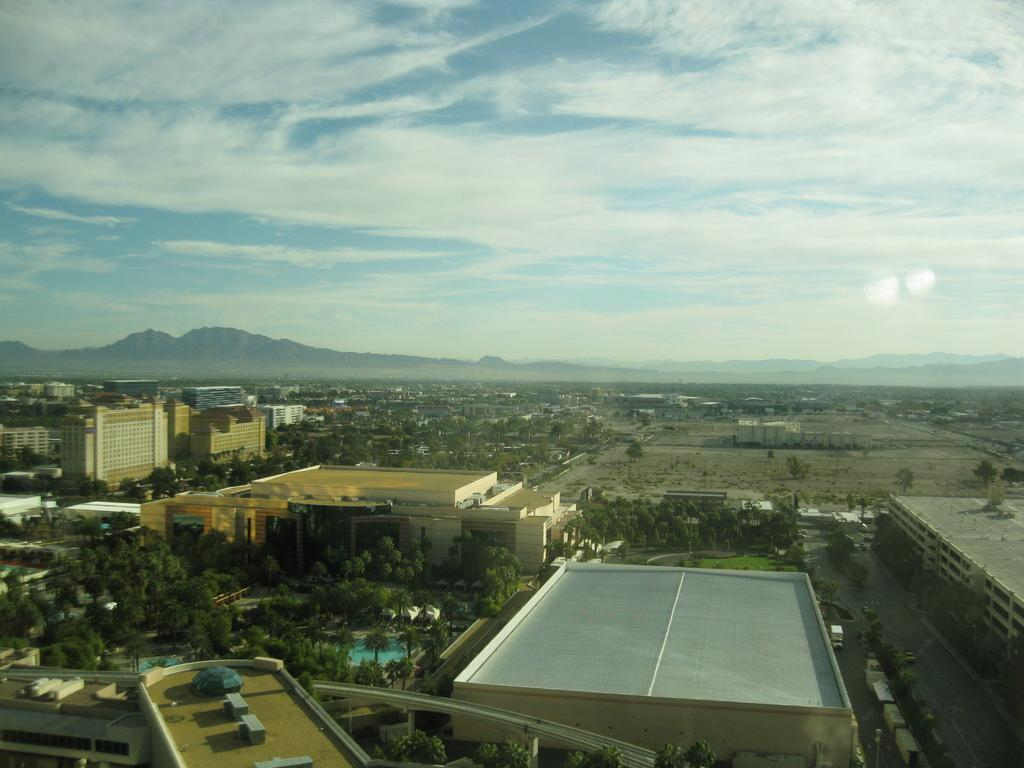What type of structures can be seen in the image? There are buildings in the image. What natural elements are present in the image? There are trees, hills, and grass in the image. What is visible on the ground in the image? There are objects on the ground in the image. What type of transportation is visible in the image? There are vehicles in the image. What part of the natural environment is visible in the image? The ground, trees, hills, and grass are visible in the image. What is visible in the sky in the image? The sky is visible in the image, and there are clouds present. What type of star can be seen in the image? There is no star visible in the image; it features buildings, trees, hills, grass, vehicles, and clouds. What is the base of the trees in the image? The base of the trees is not visible in the image, as it only shows the trunks and leaves. 